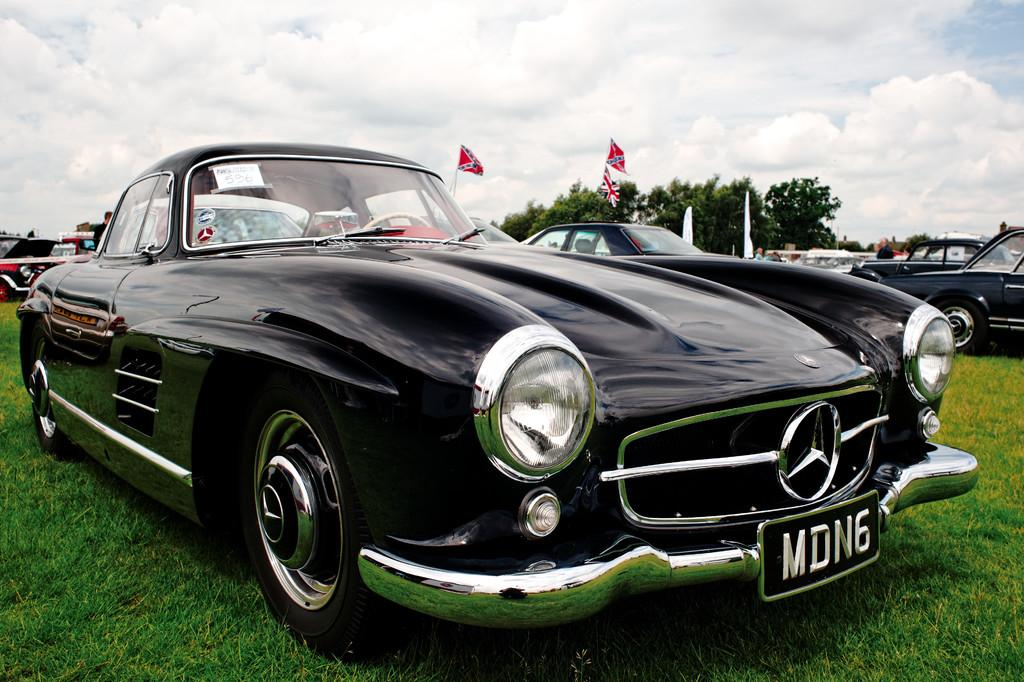What is unusual about the location of the cars in the image? The cars are parked on the grass in the image. What can be seen in the distance in the image? There are flags and trees in the background of the image. What is visible in the sky in the image? The sky is visible in the background of the image. What is the limit or cap on the number of knees visible in the image? There is no mention of knees in the image, so it is not possible to determine a limit or cap on their visibility. 